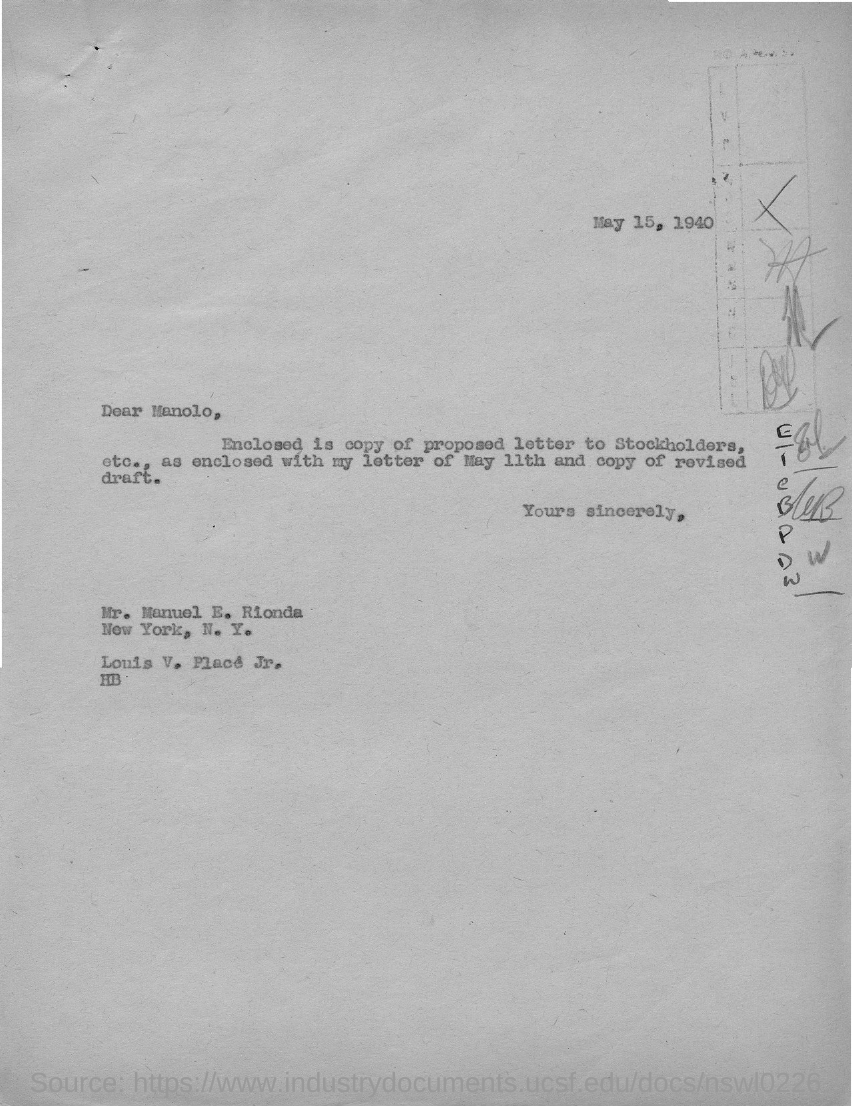What is the date mentioned in this letter?
Offer a terse response. MAY 15, 1940. Who is the sender of this letter?
Offer a very short reply. Louis V. Place Jr. Who is the addressee of this letter?
Provide a short and direct response. MANOLO. 